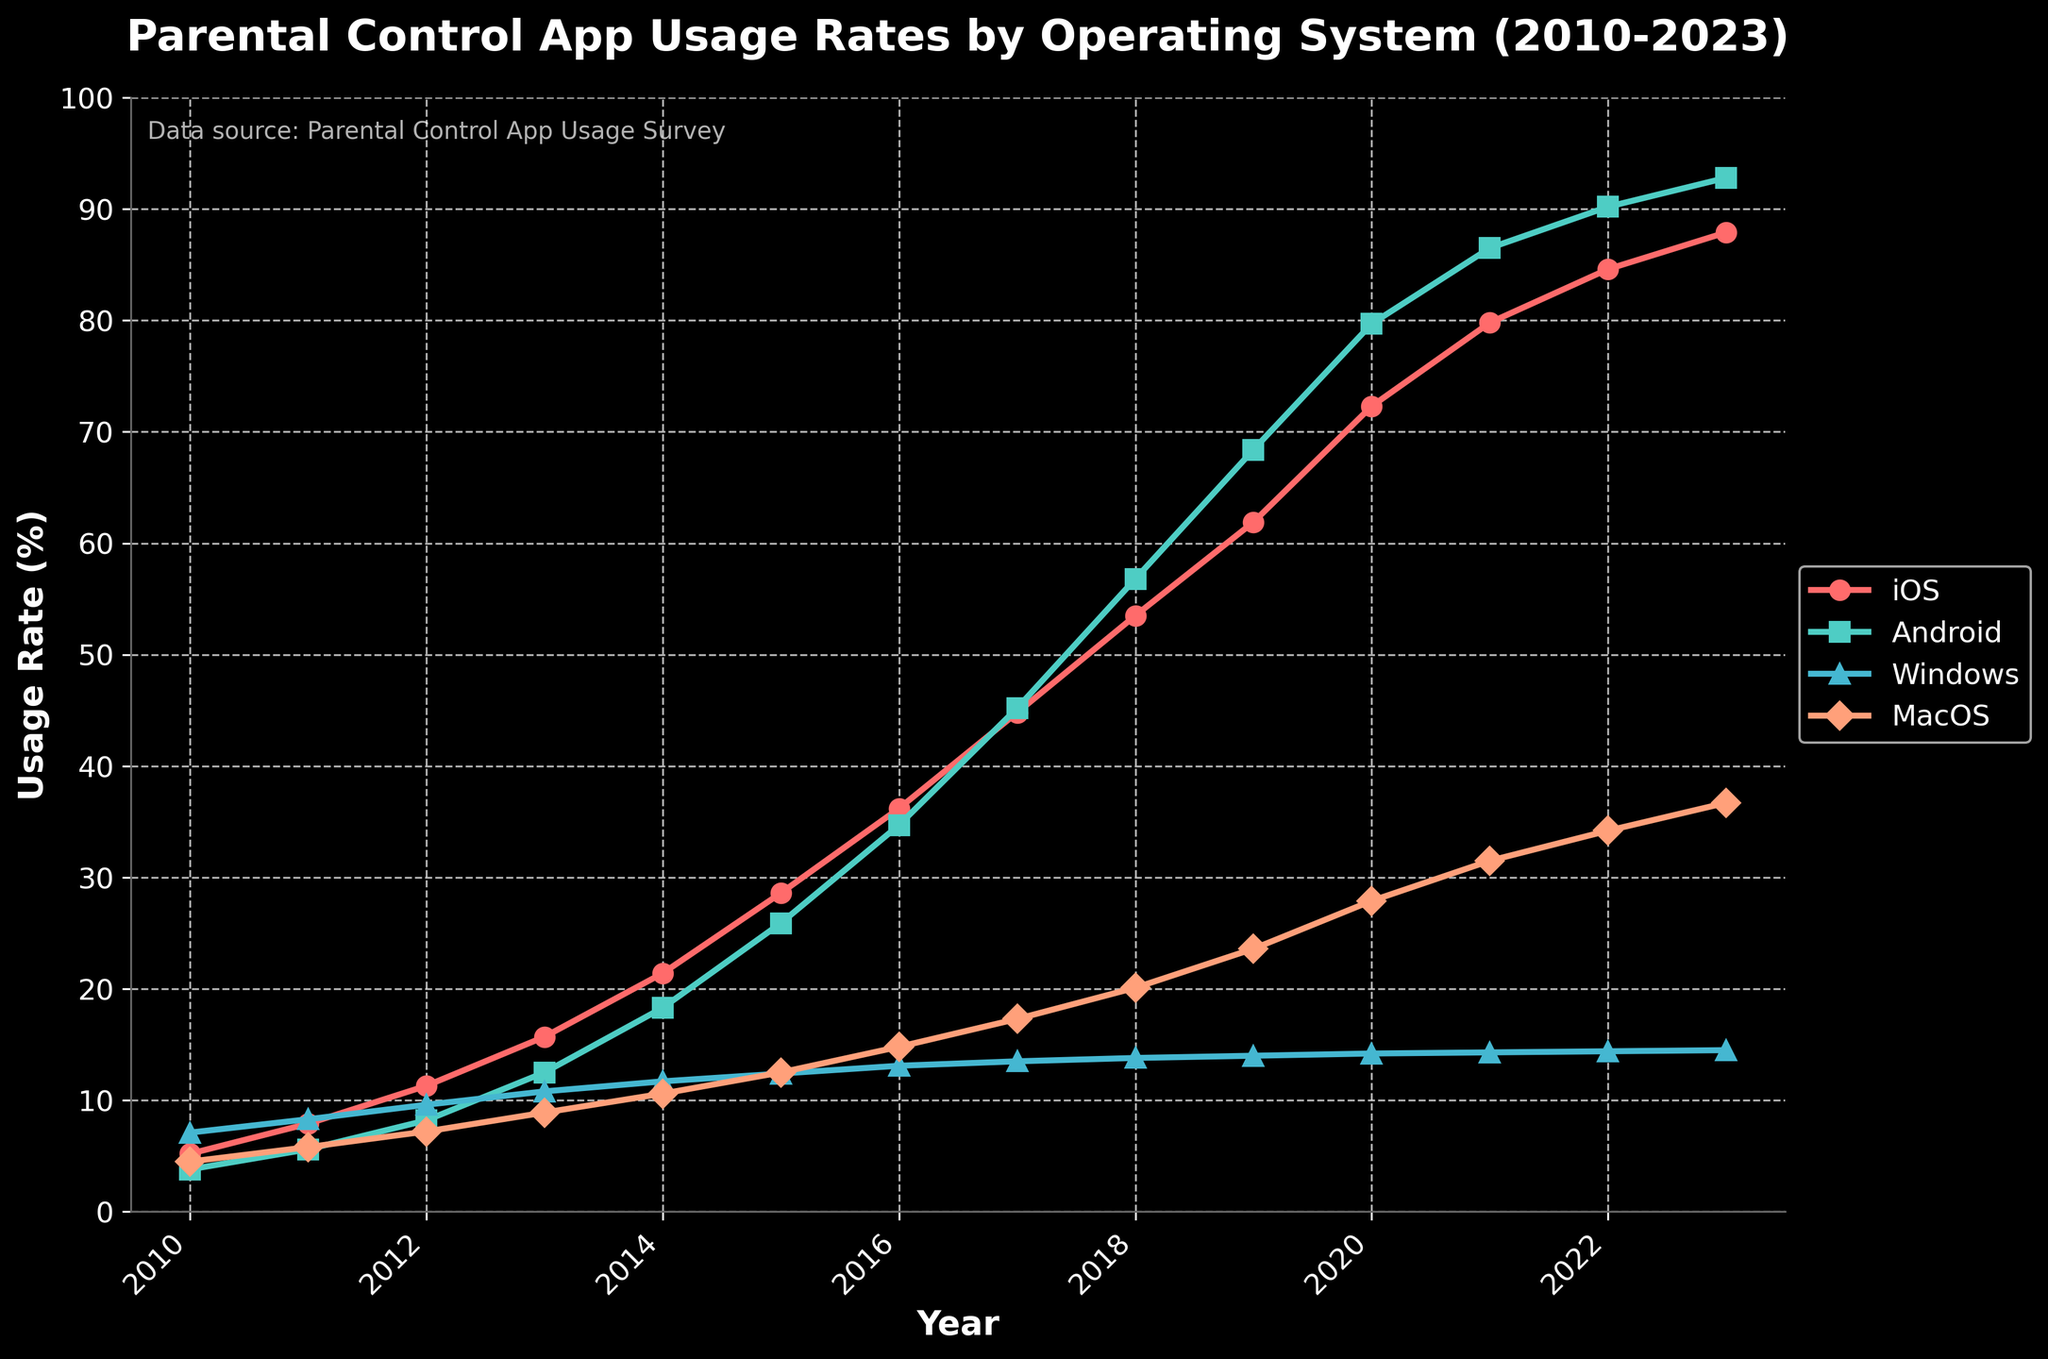What is the overall trend in the usage rates of parental control apps on iOS from 2010 to 2023? The usage rate of parental control apps on iOS shows a consistent upward trend from 5.2% in 2010 to 87.9% in 2023, indicating a steady increase in adoption over the years.
Answer: Increasing Which operating system had the highest usage rate of parental control apps in 2023? The operating system with the highest usage rate in 2023 is Android, with a usage rate of 92.8%.
Answer: Android In which year did Android surpass iOS in terms of usage rates of parental control apps? According to the line chart, Android surpassed iOS in usage rates around 2017. Before 2017, iOS had higher or similar usage rates compared to Android. From 2017 onwards, Android consistently had higher usage rates.
Answer: 2017 By how much did the usage rate of parental control apps on Windows change from 2010 to 2023? To find this, subtract the usage rate of Windows in 2010 from that in 2023. 14.5% (2023) - 7.1% (2010) = 7.4%. So, the usage rate increased by 7.4% from 2010 to 2023.
Answer: 7.4% What is the difference between the usage rates of parental control apps on MacOS and Windows in 2023? The usage rate of parental control apps on MacOS in 2023 is 36.7%, and on Windows, it is 14.5%. The difference is 36.7% - 14.5% = 22.2%.
Answer: 22.2% Which operating system showed the least growth in the usage rates of parental control apps from 2010 to 2023? Windows had the least growth. Its usage rate increased from 7.1% in 2010 to 14.5% in 2023, which is a growth of 7.4%. Other systems showed more significant increases.
Answer: Windows How does the growth rate in usage of parental control apps on Android from 2010 to 2023 compare to that on iOS? The growth rate on Android can be calculated by the difference between 2010 and 2023 values: 92.8% - 3.8% = 89.0%. On iOS, it's 87.9% - 5.2% = 82.7%. Android shows a higher growth rate (89.0%) compared to iOS (82.7%).
Answer: Android had a higher growth rate Between which consecutive years did MacOS see the largest increase in the usage rates of parental control apps? MacOS saw the largest increase between 2019 and 2020, where the usage rate went from 23.6% (2019) to 27.9% (2020), an increase of 4.3%.
Answer: Between 2019 and 2020 What color represents the usage rates of parental control apps on MacOS in the line chart? The line representing the usage rates of parental control apps on MacOS in the chart is colored orange.
Answer: Orange Calculate the average annual increase in the usage rate of parental control apps on iOS from 2010 to 2023. To calculate the average annual increase, first find the total increase: 87.9% (2023) - 5.2% (2010) = 82.7%. There are 13 years between 2010 and 2023. So, the average annual increase is 82.7% / 13 ≈ 6.36%.
Answer: Approximately 6.36% 